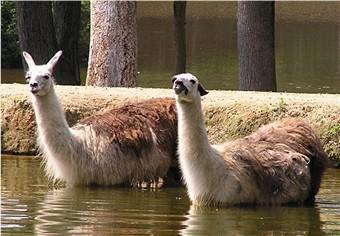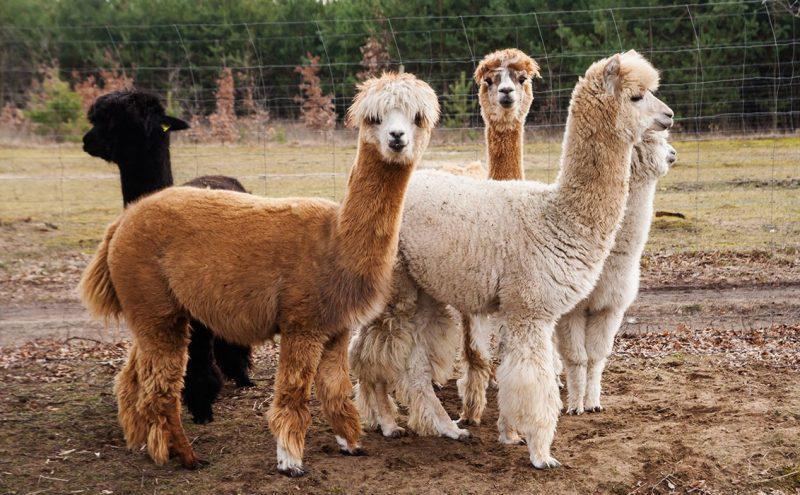The first image is the image on the left, the second image is the image on the right. Considering the images on both sides, is "IN at least one image there are six llamas standing on grass." valid? Answer yes or no. No. The first image is the image on the left, the second image is the image on the right. Analyze the images presented: Is the assertion "An image shows just one llama, which is standing in profile on dry ground, with its face and body turned the same way." valid? Answer yes or no. No. 